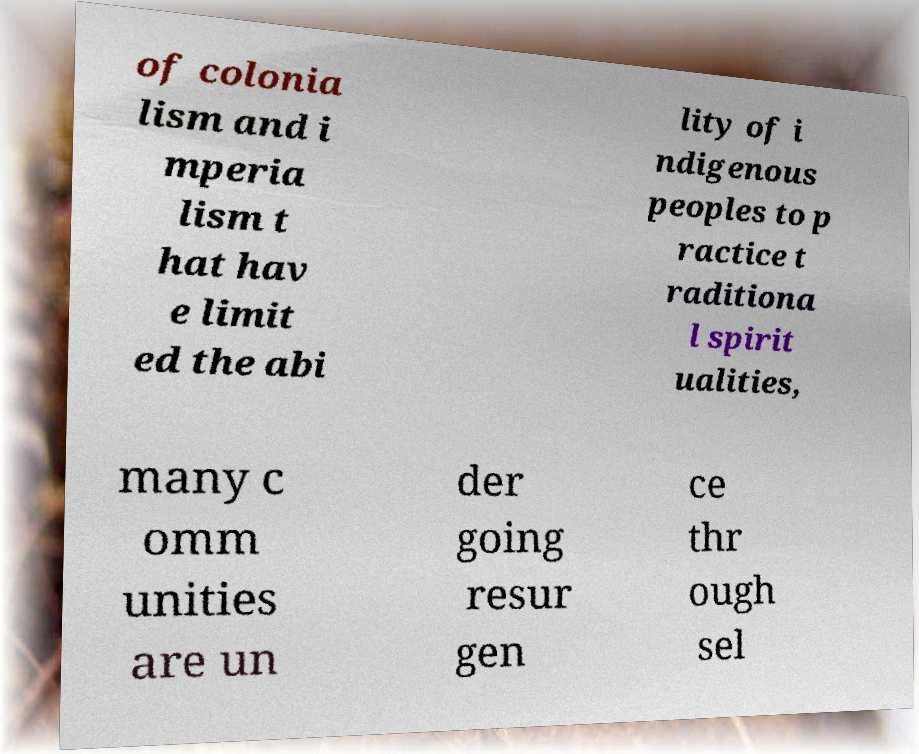For documentation purposes, I need the text within this image transcribed. Could you provide that? of colonia lism and i mperia lism t hat hav e limit ed the abi lity of i ndigenous peoples to p ractice t raditiona l spirit ualities, many c omm unities are un der going resur gen ce thr ough sel 